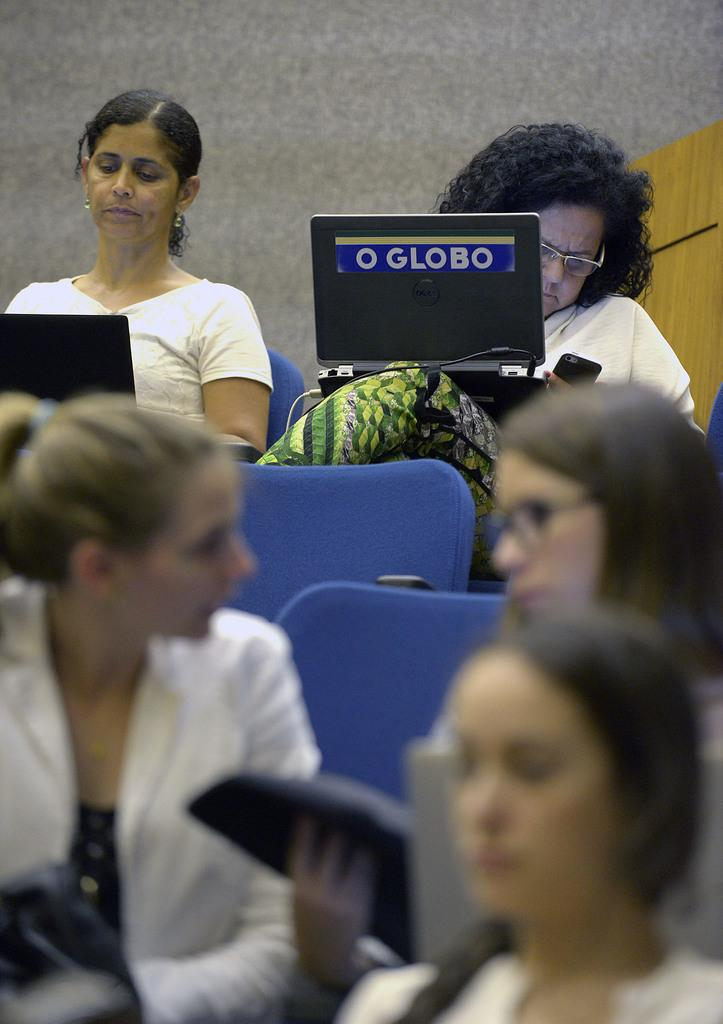What are the people in the image doing? The people in the image are sitting on chairs and operating laptops. Can you describe the setting in which the people are working? There appears to be a wall in the background. What type of mint can be seen growing on the wall in the image? There is no mint visible in the image, as the focus is on the people and their laptops. 